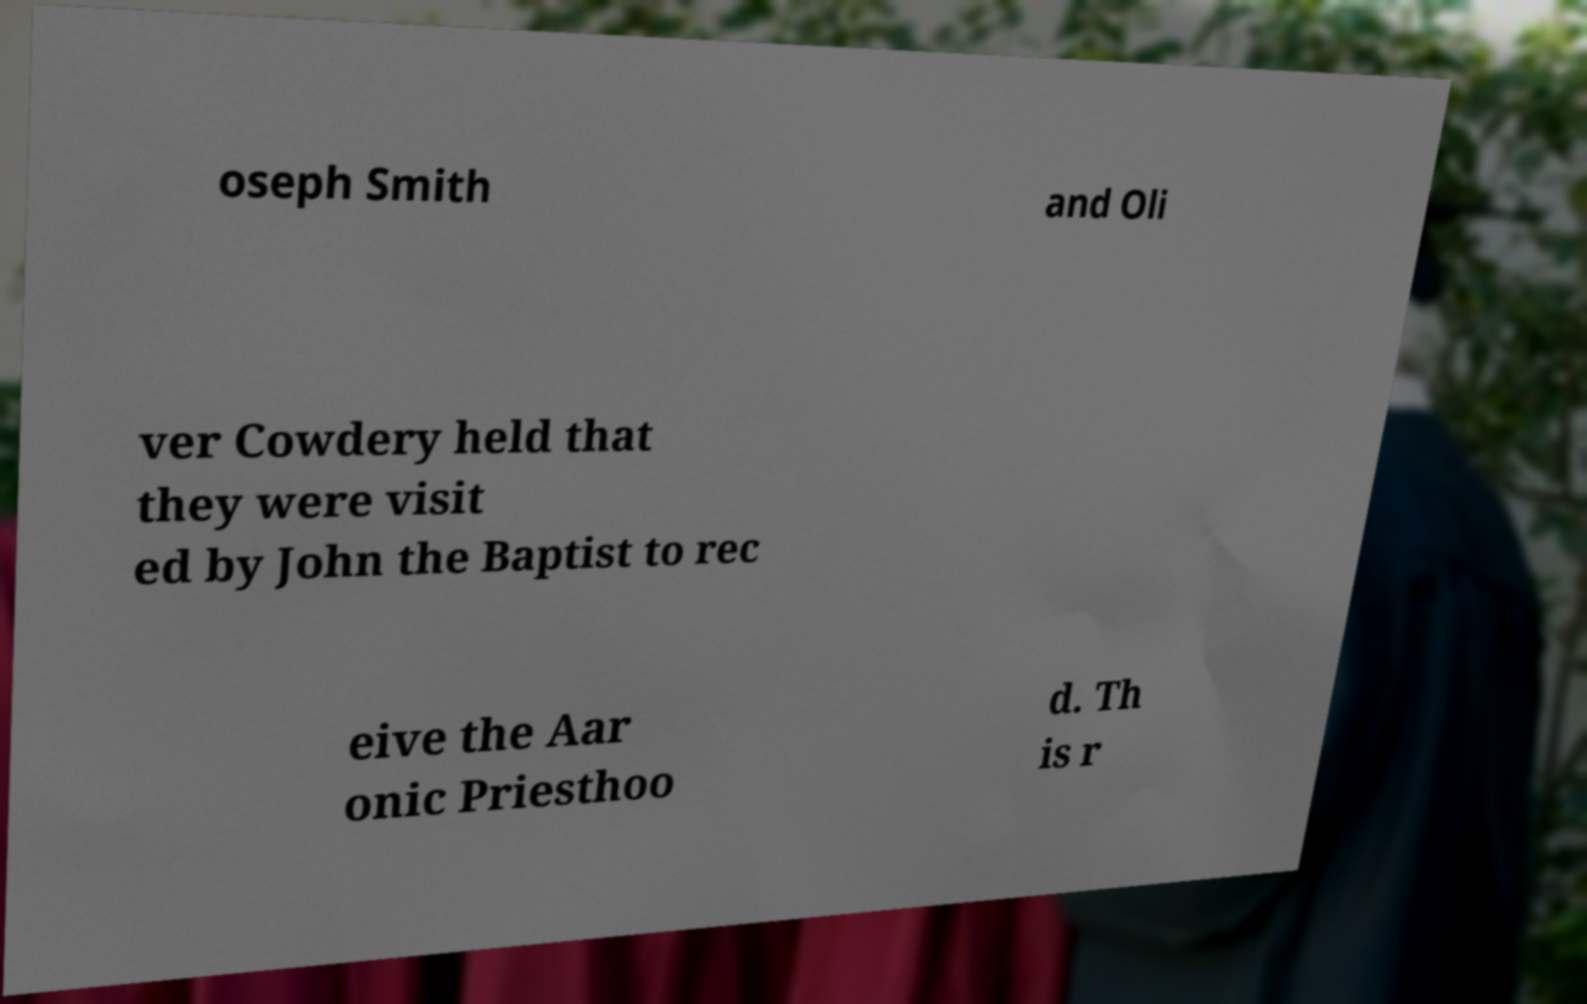Can you read and provide the text displayed in the image?This photo seems to have some interesting text. Can you extract and type it out for me? oseph Smith and Oli ver Cowdery held that they were visit ed by John the Baptist to rec eive the Aar onic Priesthoo d. Th is r 